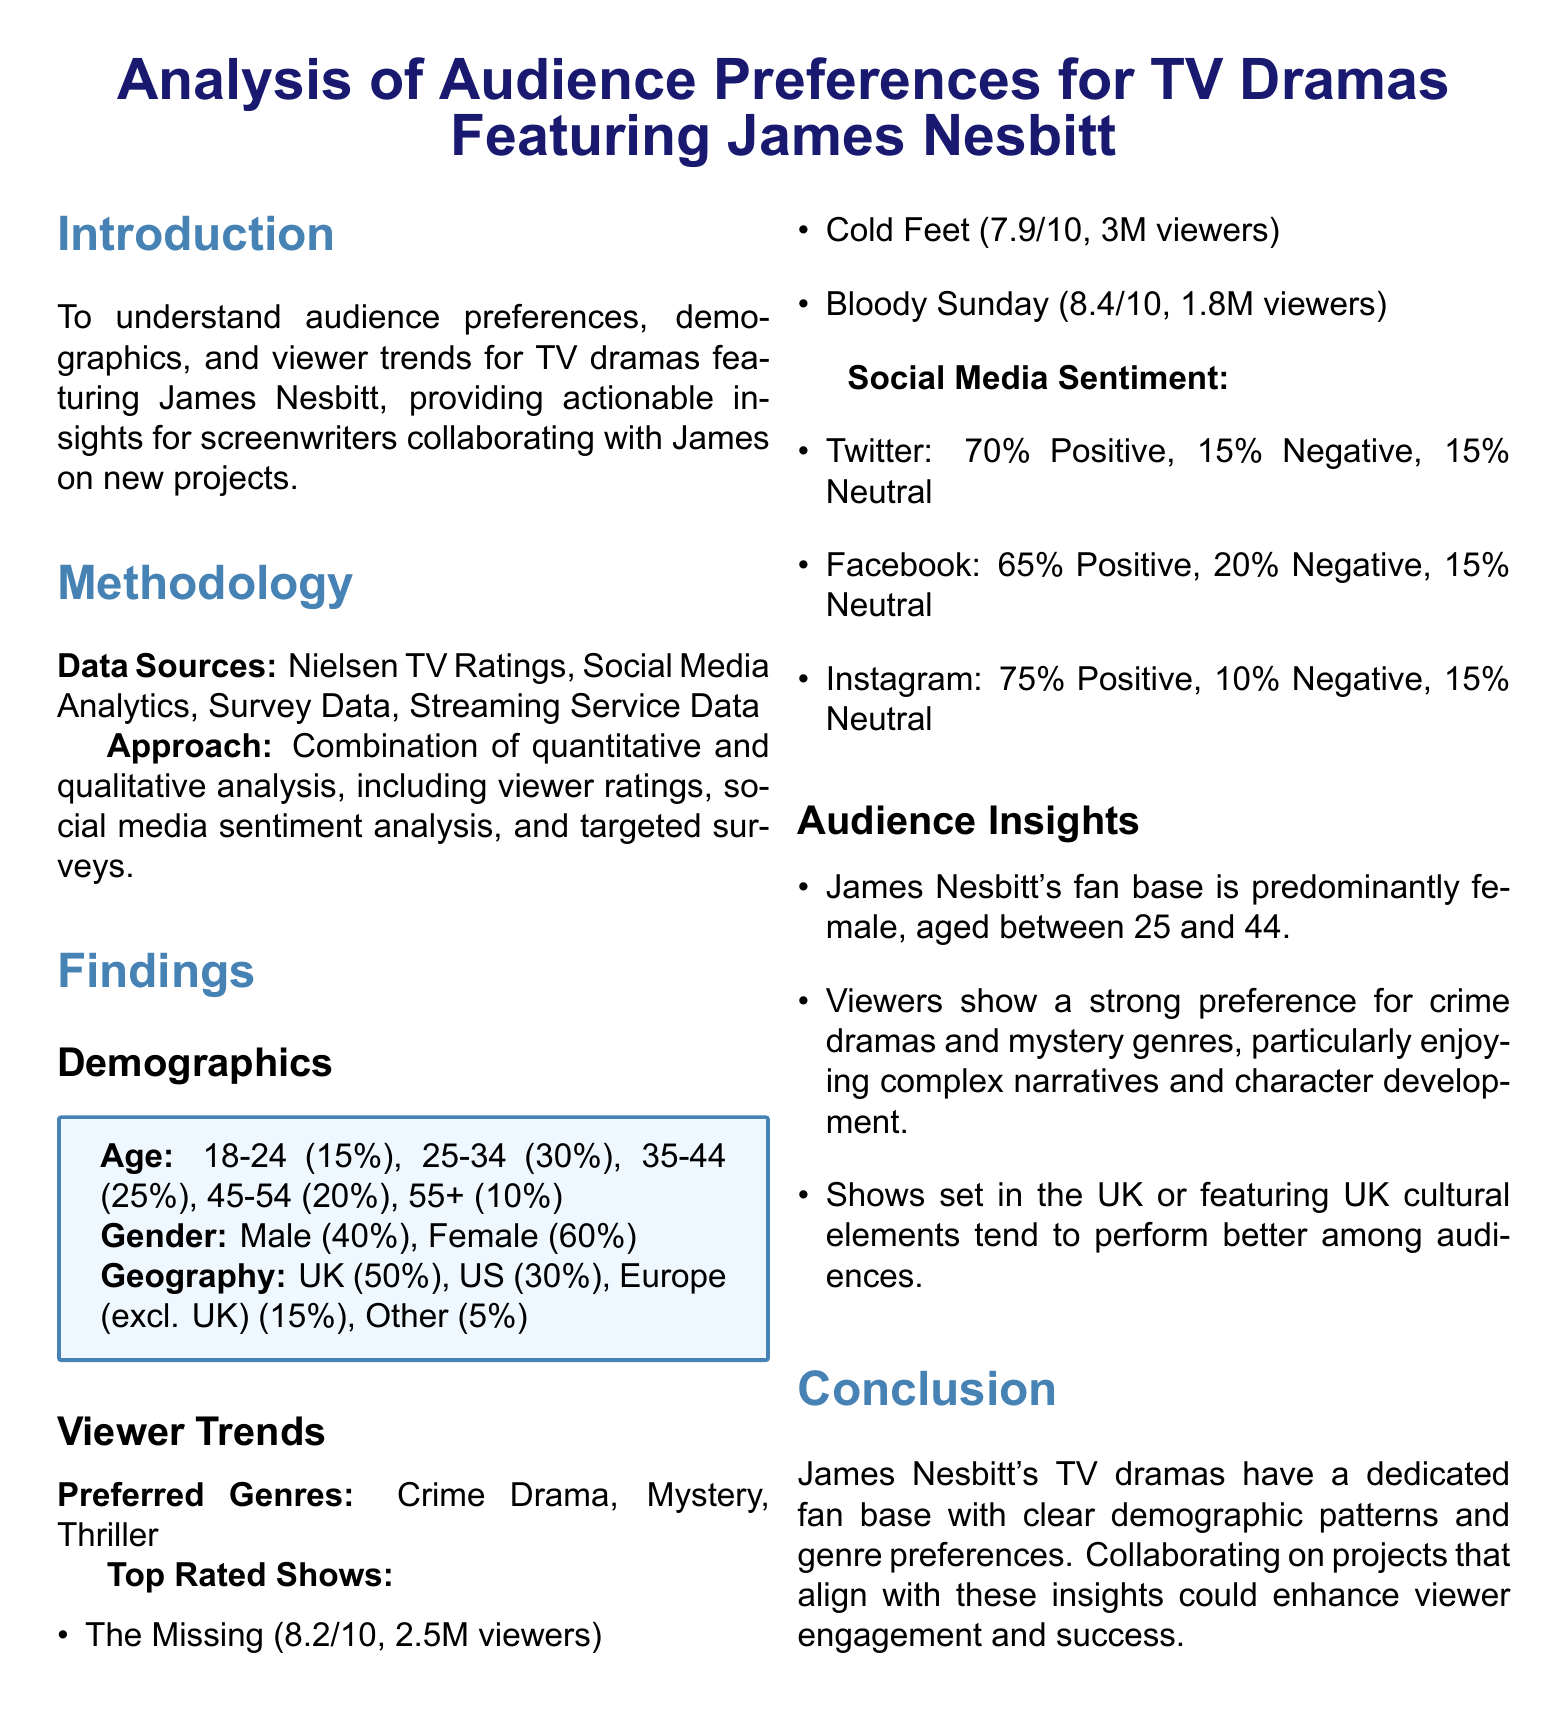What is the age demographic with the highest percentage? The demographic with the highest percentage is determined from the age breakdown provided in the document, which shows 25-34 at 30%.
Answer: 25-34 What percentage of viewers are female? The document specifies the gender breakdown, noting that females make up 60% of the viewers.
Answer: 60% What is the average rating of "The Missing"? The document lists the rating for "The Missing," which is 8.2 out of 10.
Answer: 8.2 Which social media platform has the highest positive sentiment? The positive sentiment percentages for social media platforms indicate that Instagram has the highest at 75%.
Answer: Instagram What genre preference is most popular among the audience? The section on viewer trends identifies crime drama as the preferred genre by the audience.
Answer: Crime Drama What percentage of viewers are located in the UK? The geographical data indicates that 50% of viewers are from the UK.
Answer: 50% How many viewers did "Cold Feet" have? The document provides a viewer count for "Cold Feet," which is 3 million viewers.
Answer: 3M viewers What is the total percentage of positive sentiment for Twitter? The positive sentiment on Twitter is explicitly stated as 70%.
Answer: 70% What data sources were used for this analysis? The document states the data sources utilized: Nielsen TV Ratings, Social Media Analytics, Survey Data, Streaming Service Data.
Answer: Nielsen TV Ratings, Social Media Analytics, Survey Data, Streaming Service Data 